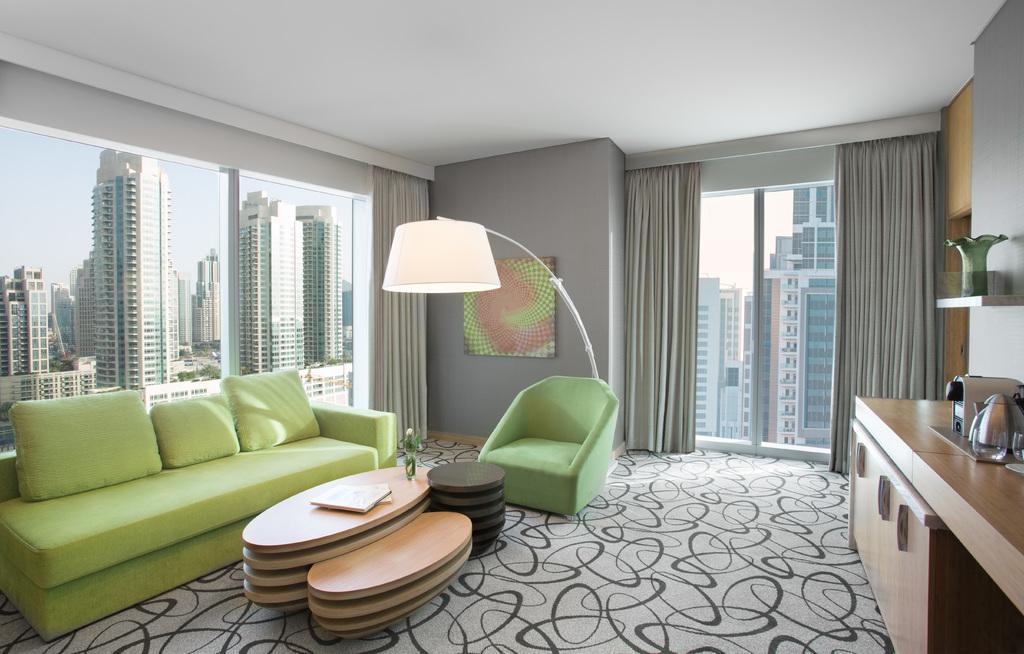Describe this image in one or two sentences. Through window glass we can see huge buildings and sky. This is a floor. This is a cupboard. Here we can see chair and sofa , pillows in green color. On the table we can see a flower vase. This is a wall. Here we can see a vase on a desk. 